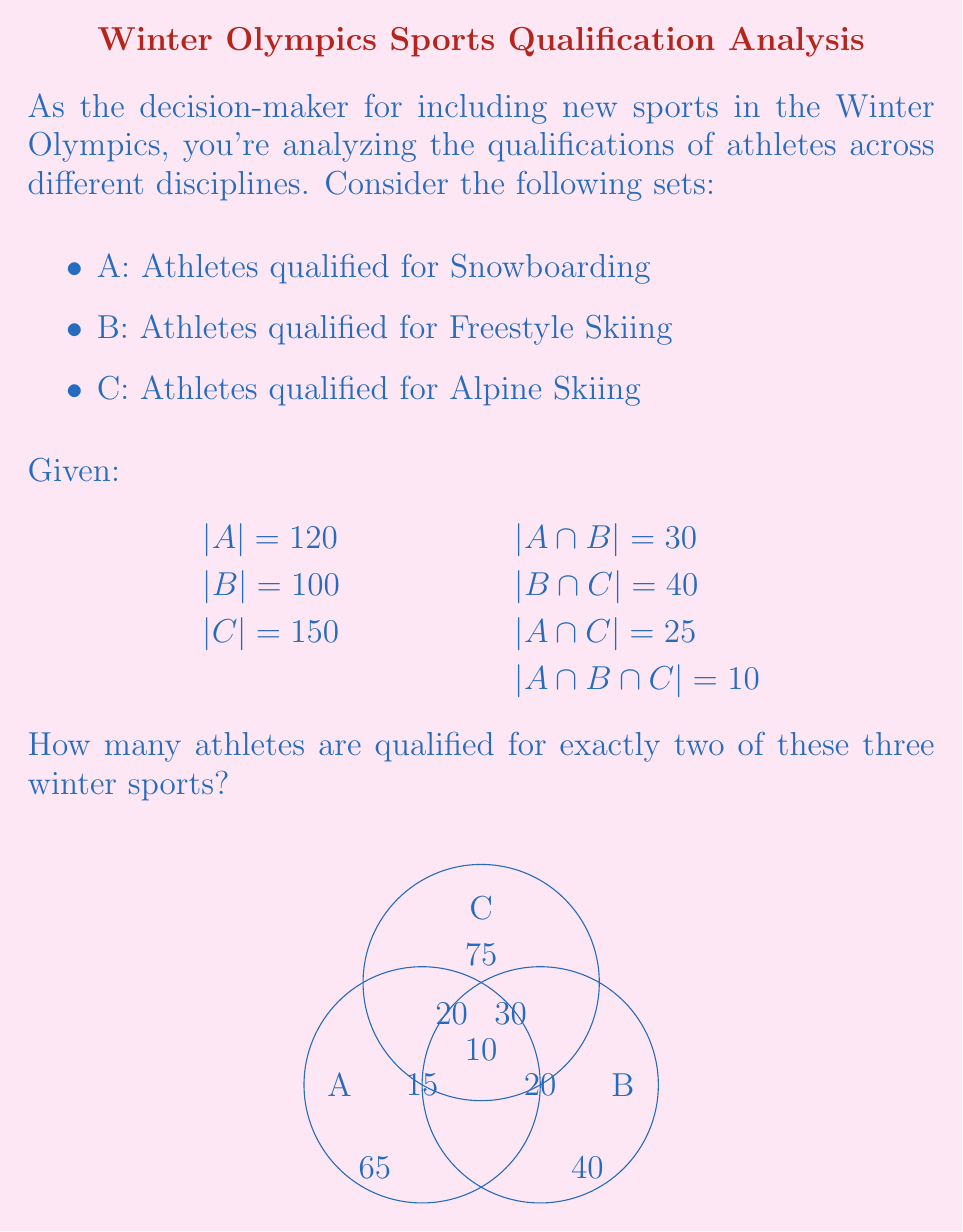Solve this math problem. Let's approach this step-by-step using the principle of inclusion-exclusion:

1) First, we need to find the total number of athletes qualified for at least two sports. This is equivalent to $|A \cap B| + |B \cap C| + |A \cap C| - 3|A \cap B \cap C|$.

   $|A \cap B| + |B \cap C| + |A \cap C| - 3|A \cap B \cap C|$
   $= 30 + 40 + 25 - 3(10)$
   $= 95 - 30 = 65$

2) However, this includes athletes qualified for all three sports. We need to subtract these to get those qualified for exactly two sports.

3) The number of athletes qualified for all three sports is given: $|A \cap B \cap C| = 10$

4) Therefore, the number of athletes qualified for exactly two sports is:
   $65 - 10 = 55$

We can verify this using the Venn diagram in the question:
20 (A∩B only) + 30 (B∩C only) + 15 (A∩C only) = 65

This matches our calculation in step 1, and subtracting the 10 in the center gives us 55.
Answer: 55 athletes 